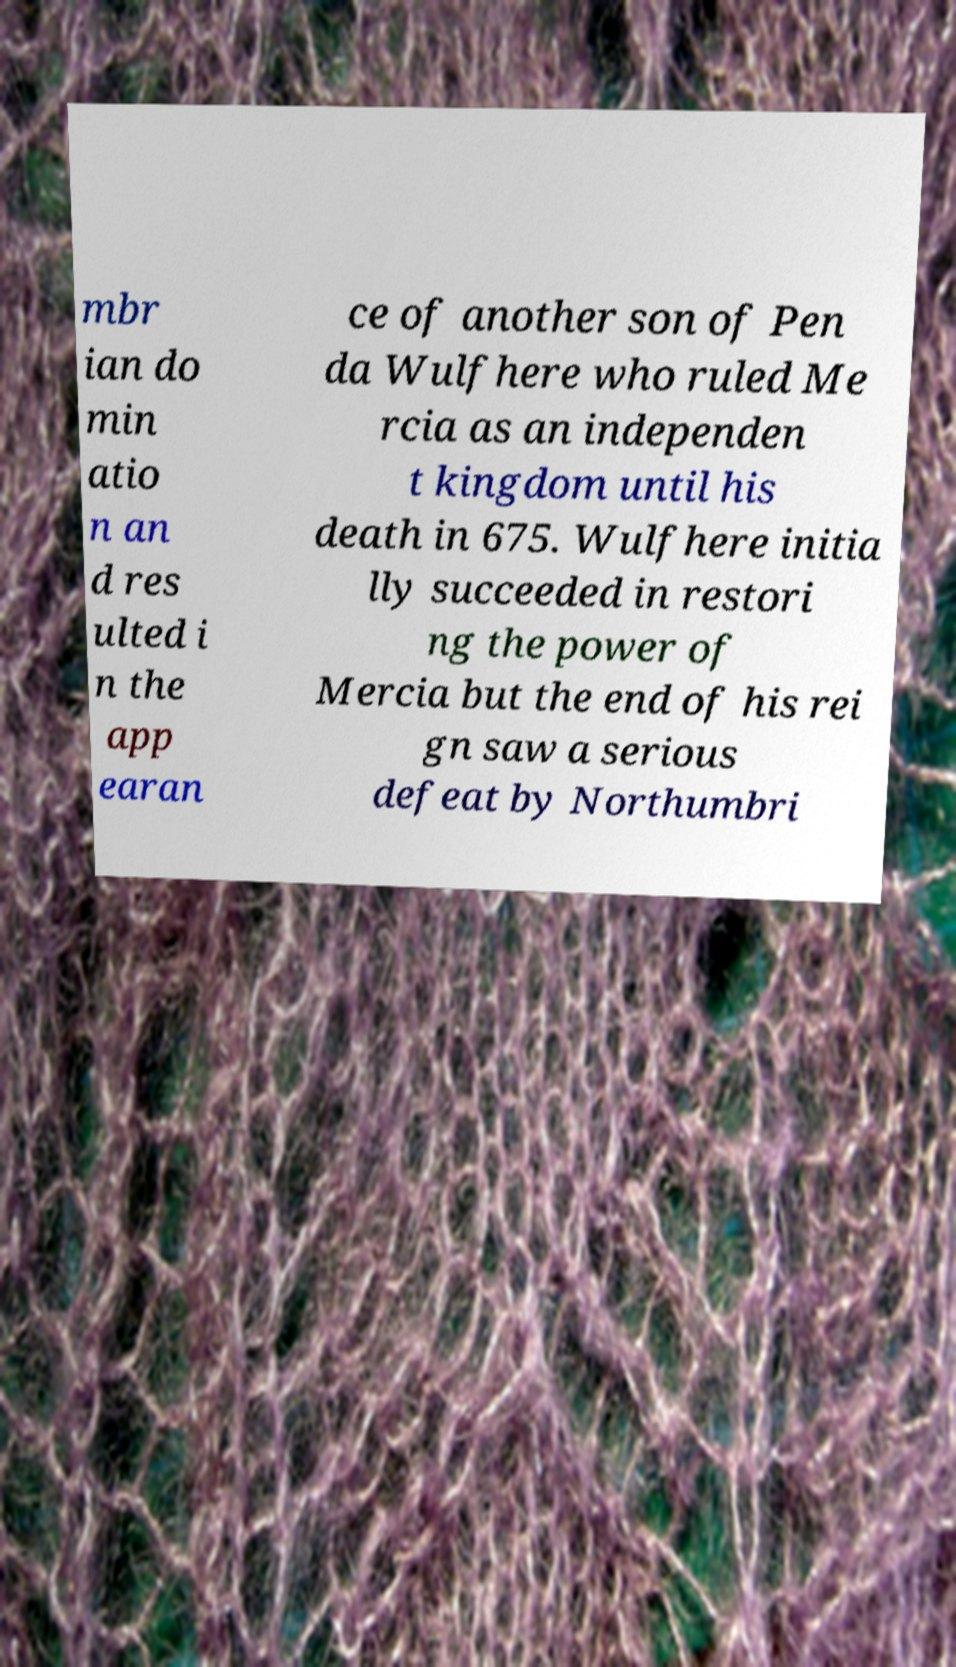I need the written content from this picture converted into text. Can you do that? mbr ian do min atio n an d res ulted i n the app earan ce of another son of Pen da Wulfhere who ruled Me rcia as an independen t kingdom until his death in 675. Wulfhere initia lly succeeded in restori ng the power of Mercia but the end of his rei gn saw a serious defeat by Northumbri 